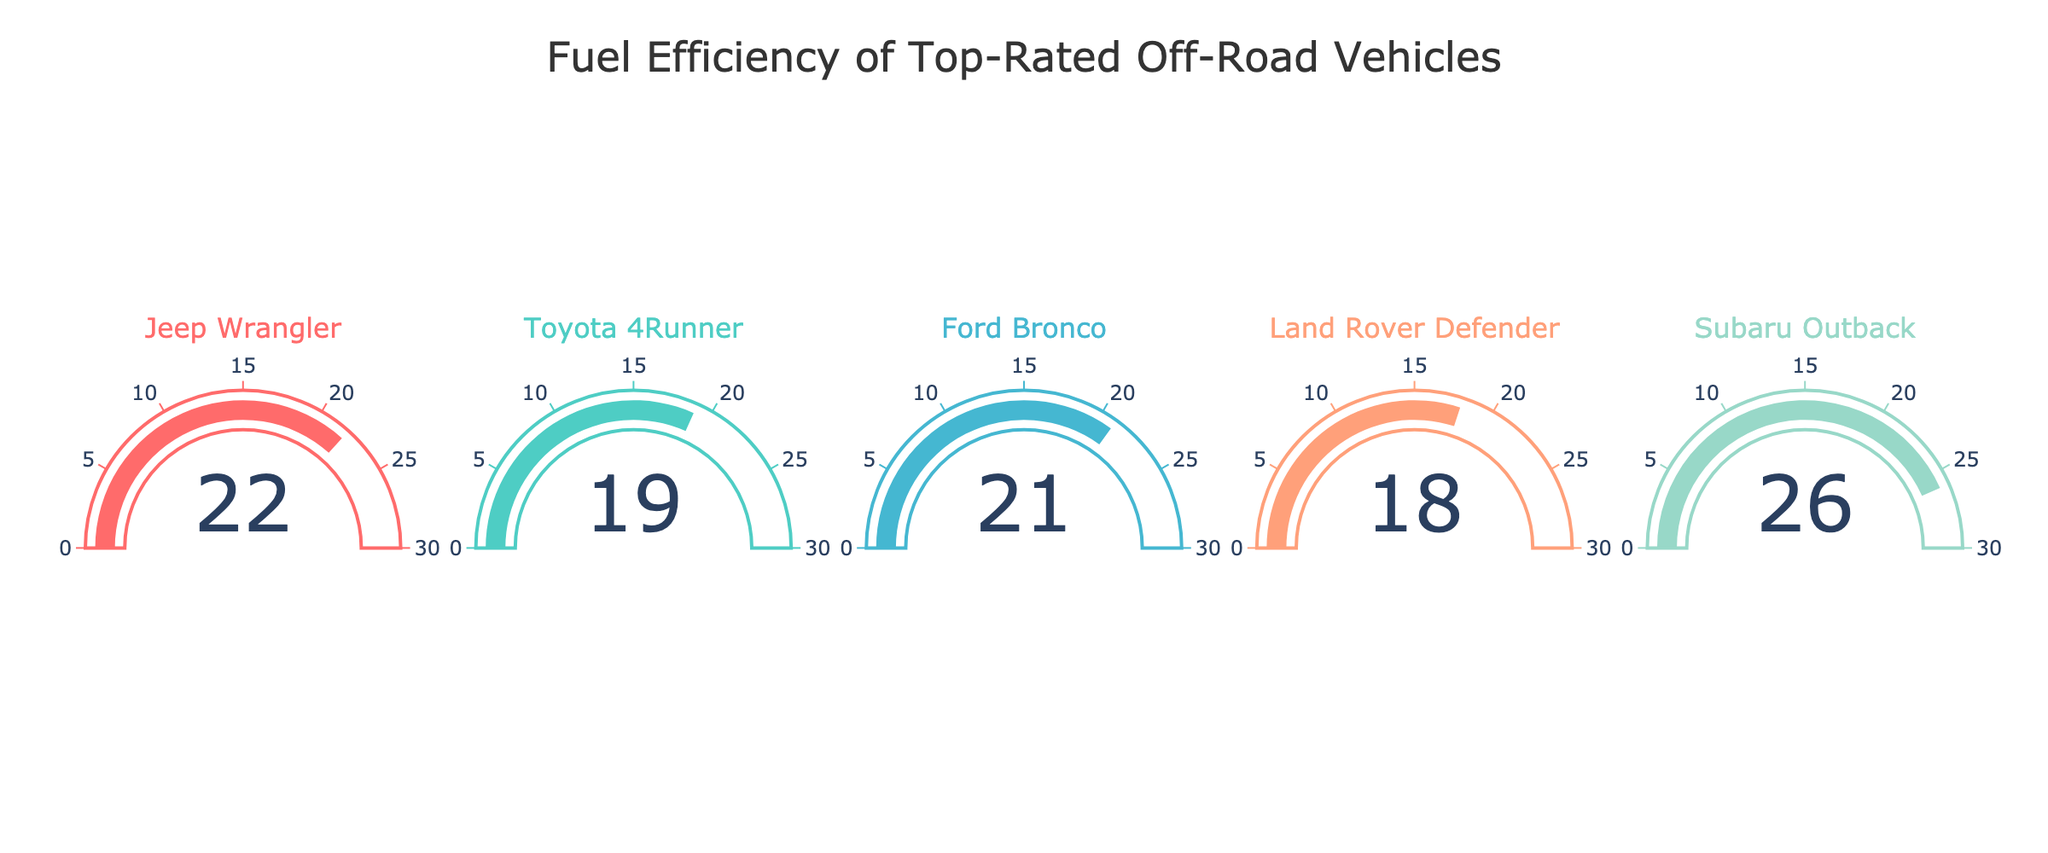What is the MPG of the Toyota 4Runner? The Toyota 4Runner's MPG can be directly read from the gauge chart.
Answer: 19 Which vehicle has the highest fuel efficiency? By comparing all the gauge values, Subaru Outback has the highest number.
Answer: Subaru Outback How much more fuel-efficient is the Subaru Outback compared to the Land Rover Defender? The Subaru Outback has an MPG of 26, and the Land Rover Defender has an MPG of 18. Subtract the Land Rover Defender's MPG from the Subaru Outback's MPG. 26 - 18 = 8.
Answer: 8 What is the average MPG across all vehicles shown? Add the MPG values of all five vehicles (22 + 19 + 21 + 18 + 26) and divide the sum by the number of vehicles (5). (22 + 19 + 21 + 18 + 26) / 5 = 21.2
Answer: 21.2 Which vehicle has the lowest fuel efficiency and what is its MPG? By comparing all the gauge values, Land Rover Defender has the lowest number.
Answer: Land Rover Defender, 18 Arrange the vehicles in descending order of their MPG. List the MPG values from highest to lowest and match them with their respective vehicles: Subaru Outback (26), Jeep Wrangler (22), Ford Bronco (21), Toyota 4Runner (19), Land Rover Defender (18).
Answer: Subaru Outback, Jeep Wrangler, Ford Bronco, Toyota 4Runner, Land Rover Defender Is the Toyota 4Runner's MPG higher or lower than the Ford Bronco's? Toyota 4Runner has an MPG of 19 and Ford Bronco has an MPG of 21. Therefore, the Toyota 4Runner's MPG is lower.
Answer: Lower What is the sum of the MPG values for the Jeep Wrangler and the Ford Bronco? Add the MPG values of Jeep Wrangler (22) and Ford Bronco (21). 22 + 21 = 43.
Answer: 43 Which vehicle falls within the middle range (most neutral gauge) of fuel efficiency? The middle range should be closer to the average value calculated earlier (21.2). Ford Bronco with an MPG of 21 is closest to this average.
Answer: Ford Bronco 